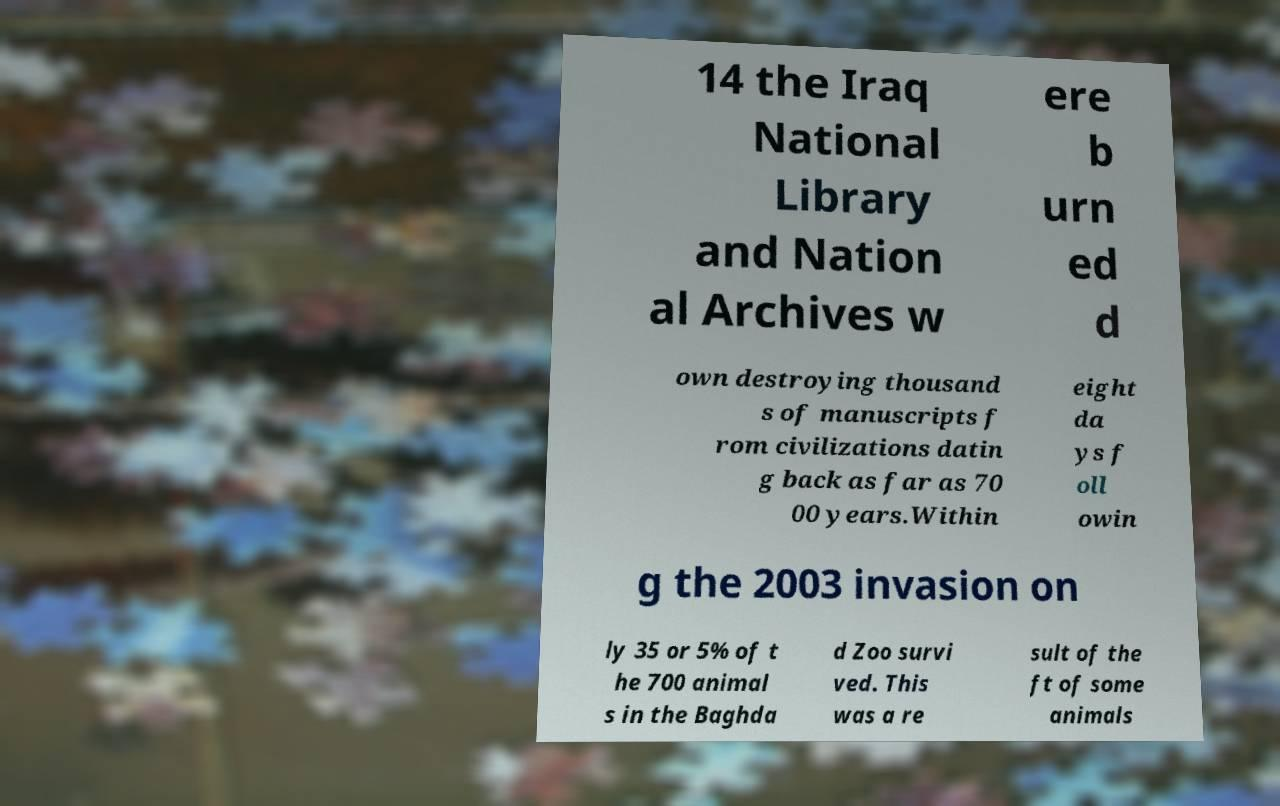Can you accurately transcribe the text from the provided image for me? 14 the Iraq National Library and Nation al Archives w ere b urn ed d own destroying thousand s of manuscripts f rom civilizations datin g back as far as 70 00 years.Within eight da ys f oll owin g the 2003 invasion on ly 35 or 5% of t he 700 animal s in the Baghda d Zoo survi ved. This was a re sult of the ft of some animals 